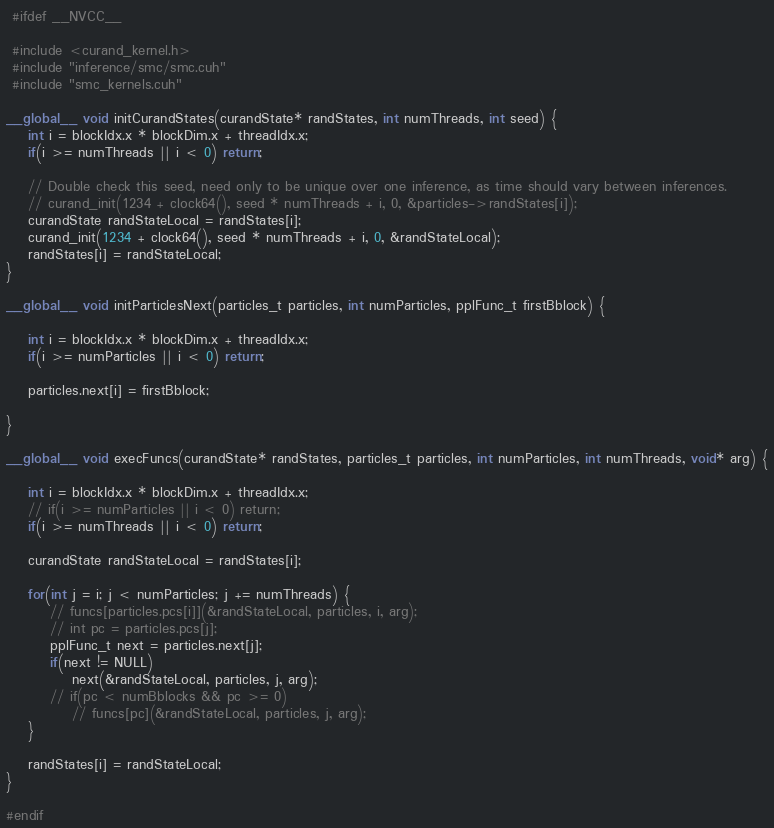Convert code to text. <code><loc_0><loc_0><loc_500><loc_500><_Cuda_>
 #ifdef __NVCC__

 #include <curand_kernel.h>
 #include "inference/smc/smc.cuh"
 #include "smc_kernels.cuh"

__global__ void initCurandStates(curandState* randStates, int numThreads, int seed) {
    int i = blockIdx.x * blockDim.x + threadIdx.x;
    if(i >= numThreads || i < 0) return;

    // Double check this seed, need only to be unique over one inference, as time should vary between inferences.
    // curand_init(1234 + clock64(), seed * numThreads + i, 0, &particles->randStates[i]);
    curandState randStateLocal = randStates[i];
    curand_init(1234 + clock64(), seed * numThreads + i, 0, &randStateLocal);
    randStates[i] = randStateLocal;
}

__global__ void initParticlesNext(particles_t particles, int numParticles, pplFunc_t firstBblock) {

    int i = blockIdx.x * blockDim.x + threadIdx.x;
    if(i >= numParticles || i < 0) return;

    particles.next[i] = firstBblock;

}

__global__ void execFuncs(curandState* randStates, particles_t particles, int numParticles, int numThreads, void* arg) {

    int i = blockIdx.x * blockDim.x + threadIdx.x;
    // if(i >= numParticles || i < 0) return;
    if(i >= numThreads || i < 0) return;

    curandState randStateLocal = randStates[i];

    for(int j = i; j < numParticles; j += numThreads) {
        // funcs[particles.pcs[i]](&randStateLocal, particles, i, arg);
        // int pc = particles.pcs[j];
        pplFunc_t next = particles.next[j];
        if(next != NULL)
            next(&randStateLocal, particles, j, arg);
        // if(pc < numBblocks && pc >= 0)
            // funcs[pc](&randStateLocal, particles, j, arg);
    }

    randStates[i] = randStateLocal;
}

#endif
</code> 